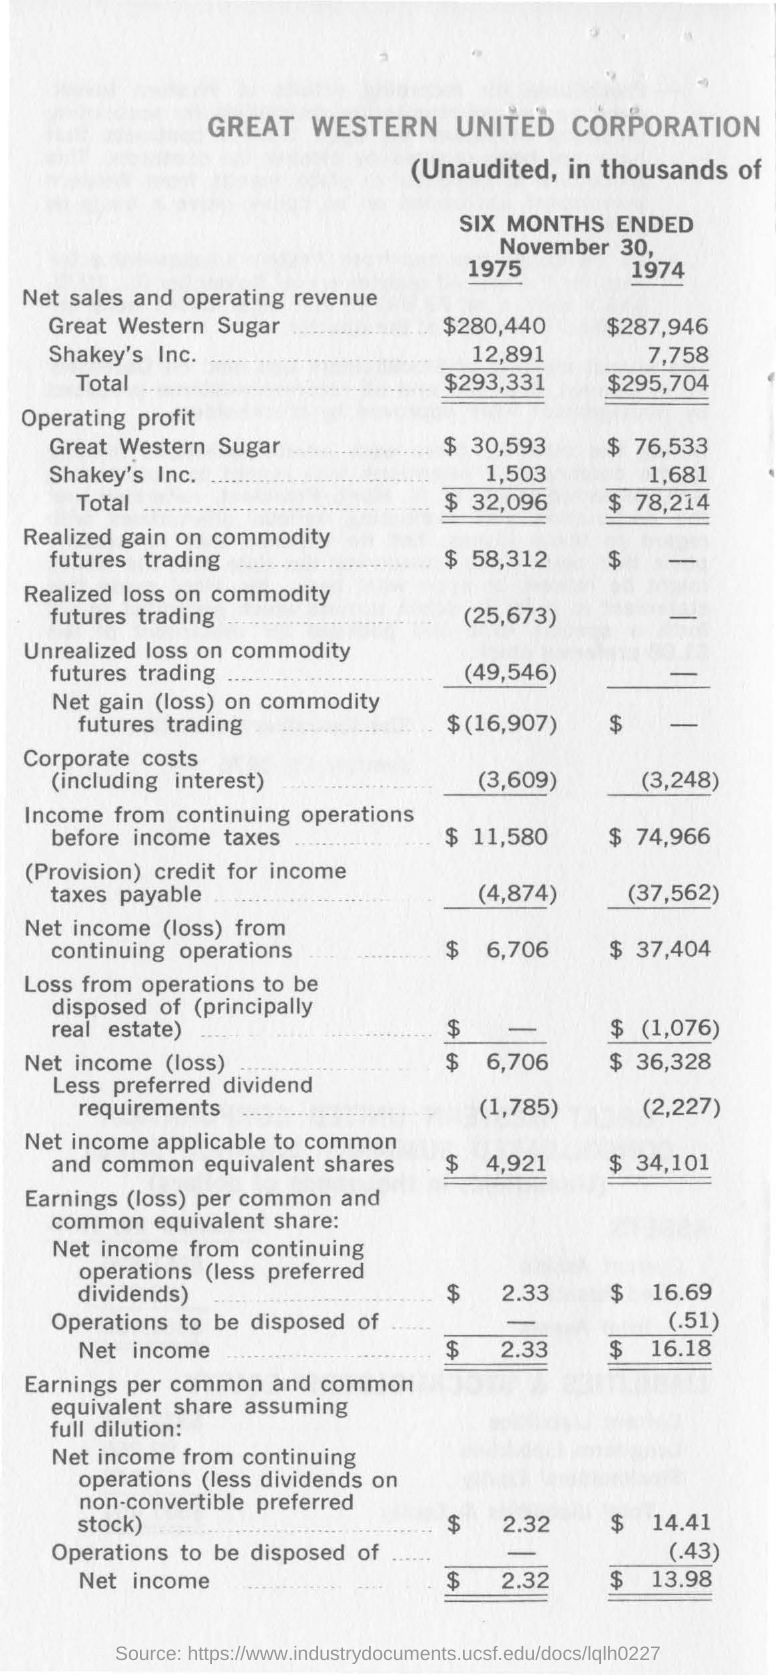Indicate a few pertinent items in this graphic. The net sales and operating revenue for Great Western Sugar in 1974 was 287,946. The operating profit for Shakey's Inc. in 1974 was 1,681. In 1975, the net sales and operating revenue for Great Western Sugar was $280,440. 